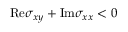Convert formula to latex. <formula><loc_0><loc_0><loc_500><loc_500>R e \sigma _ { x y } + I m \sigma _ { x x } < 0</formula> 